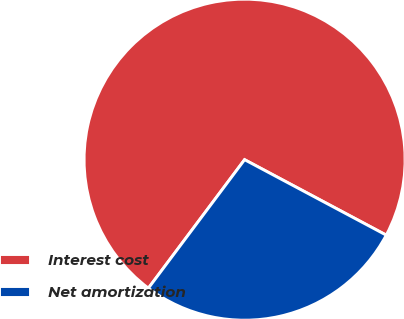Convert chart. <chart><loc_0><loc_0><loc_500><loc_500><pie_chart><fcel>Interest cost<fcel>Net amortization<nl><fcel>72.56%<fcel>27.44%<nl></chart> 